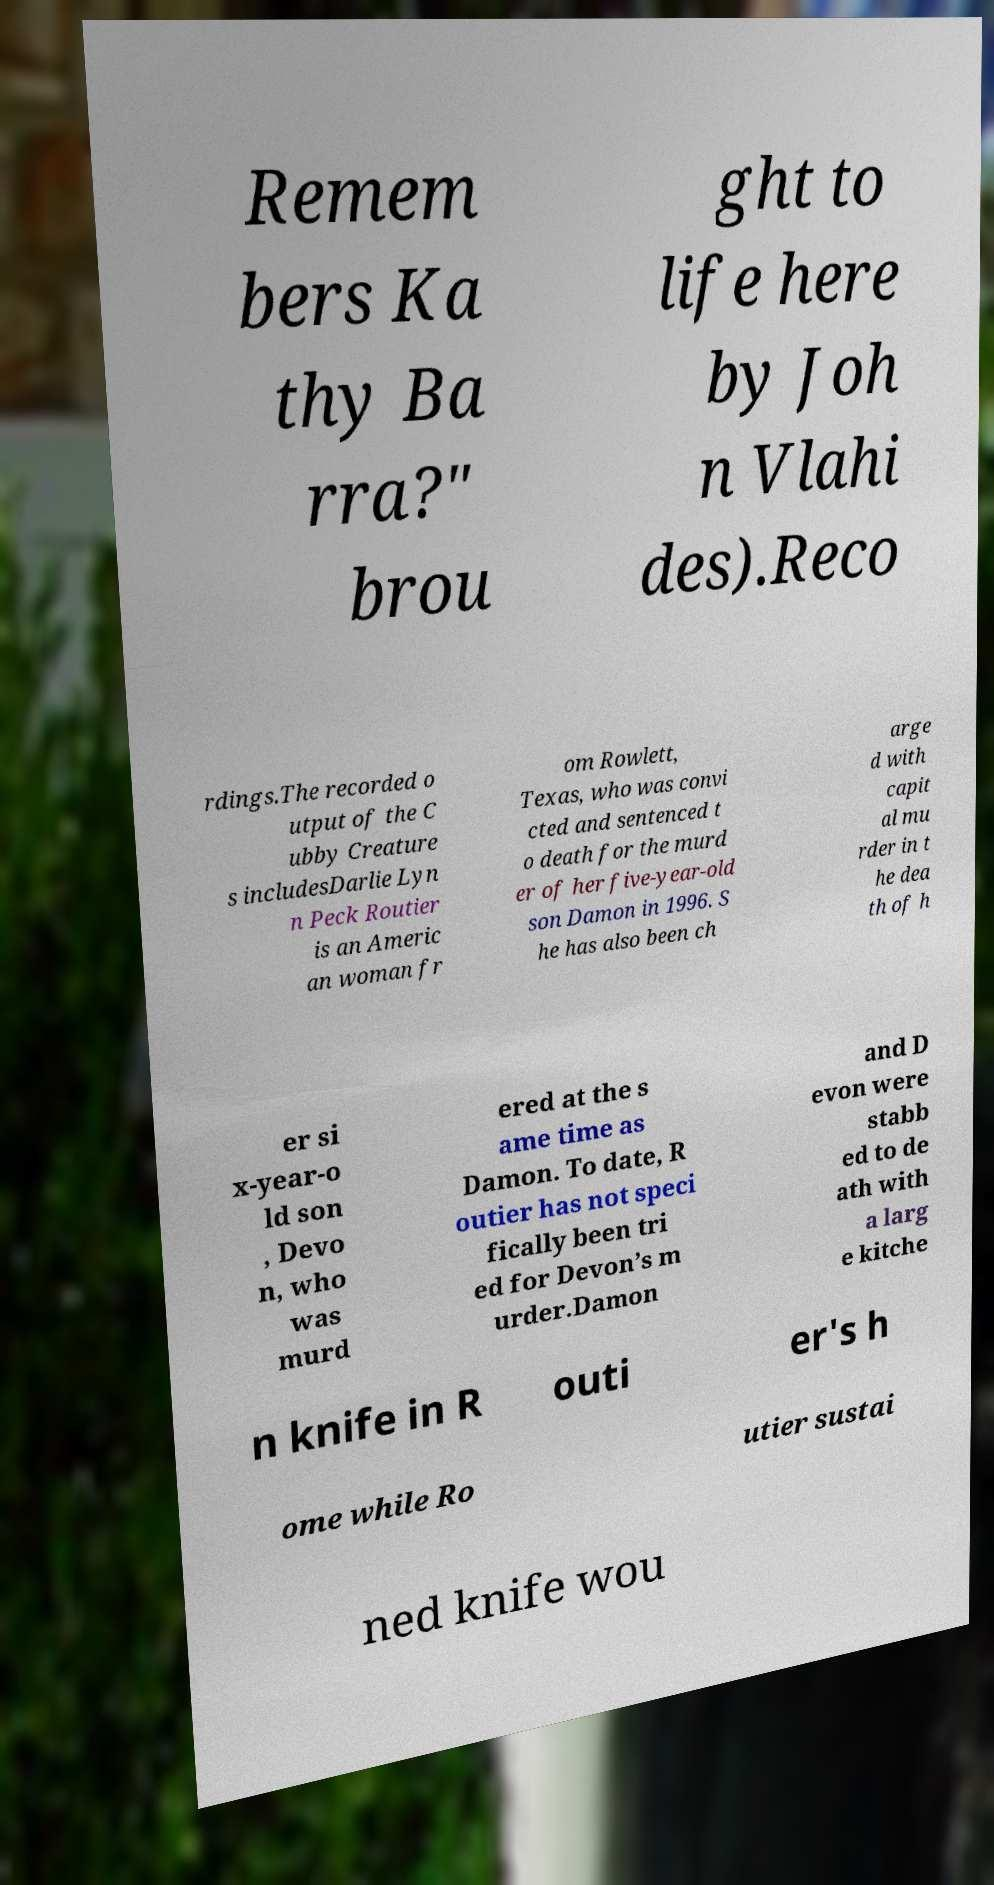Please identify and transcribe the text found in this image. Remem bers Ka thy Ba rra?" brou ght to life here by Joh n Vlahi des).Reco rdings.The recorded o utput of the C ubby Creature s includesDarlie Lyn n Peck Routier is an Americ an woman fr om Rowlett, Texas, who was convi cted and sentenced t o death for the murd er of her five-year-old son Damon in 1996. S he has also been ch arge d with capit al mu rder in t he dea th of h er si x-year-o ld son , Devo n, who was murd ered at the s ame time as Damon. To date, R outier has not speci fically been tri ed for Devon’s m urder.Damon and D evon were stabb ed to de ath with a larg e kitche n knife in R outi er's h ome while Ro utier sustai ned knife wou 